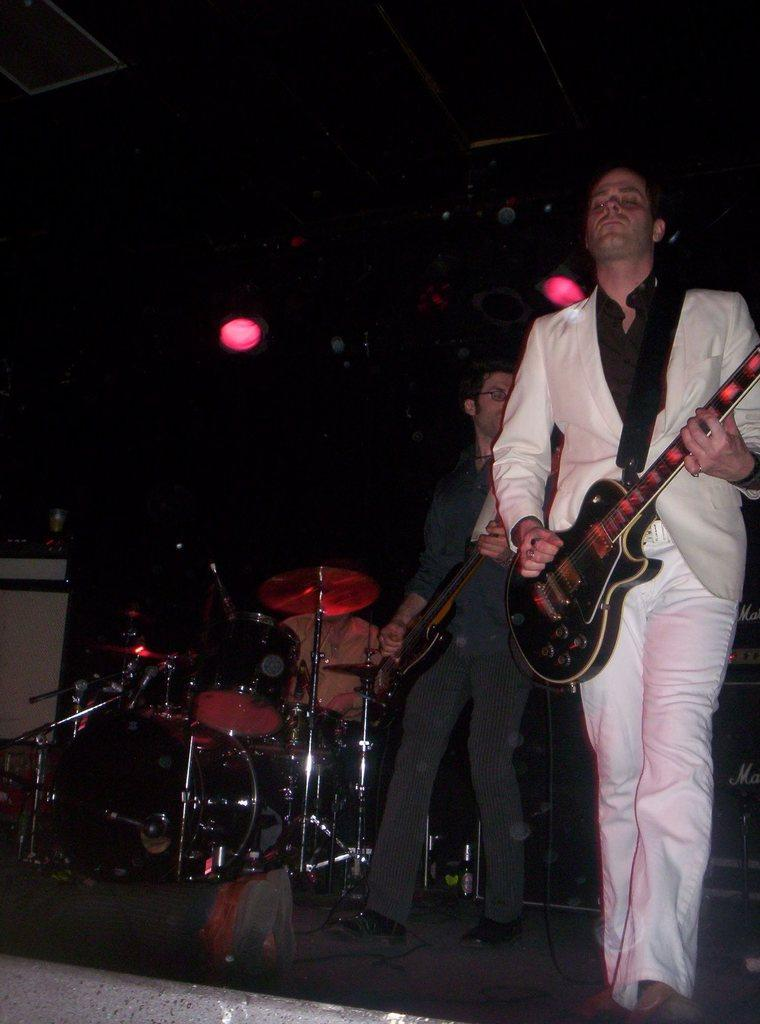How many people are in the image? There are two men in the image. What are the men doing in the image? The men are playing guitar in the image. Where are the men located in the image? The men are on a stage in the image. What else can be seen on the stage besides the men? There are musical instruments on the stage. On which side of the image is the stage located? The stage is on the left side of the image. Can you tell me how many boats are visible in the image? There are no boats present in the image. What cause might have led to the men playing guitar on the stage? The image does not provide any information about the cause or reason for the men playing guitar on the stage. 